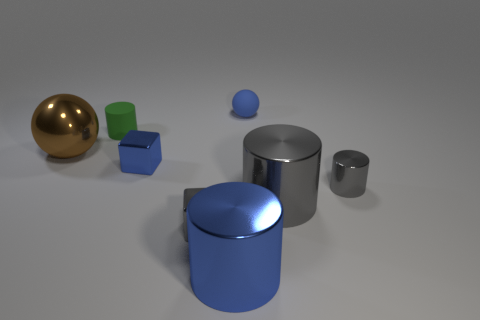Can you describe the arrangement of the objects? Certainly. The objects are laid out on a flat surface with a varied arrangement. From left to right, there's a large gold sphere, two colored cubes—one green and one blue—placed close to each other, a small blue sphere, and several cylinders of different sizes in both gray and shiny silver. 